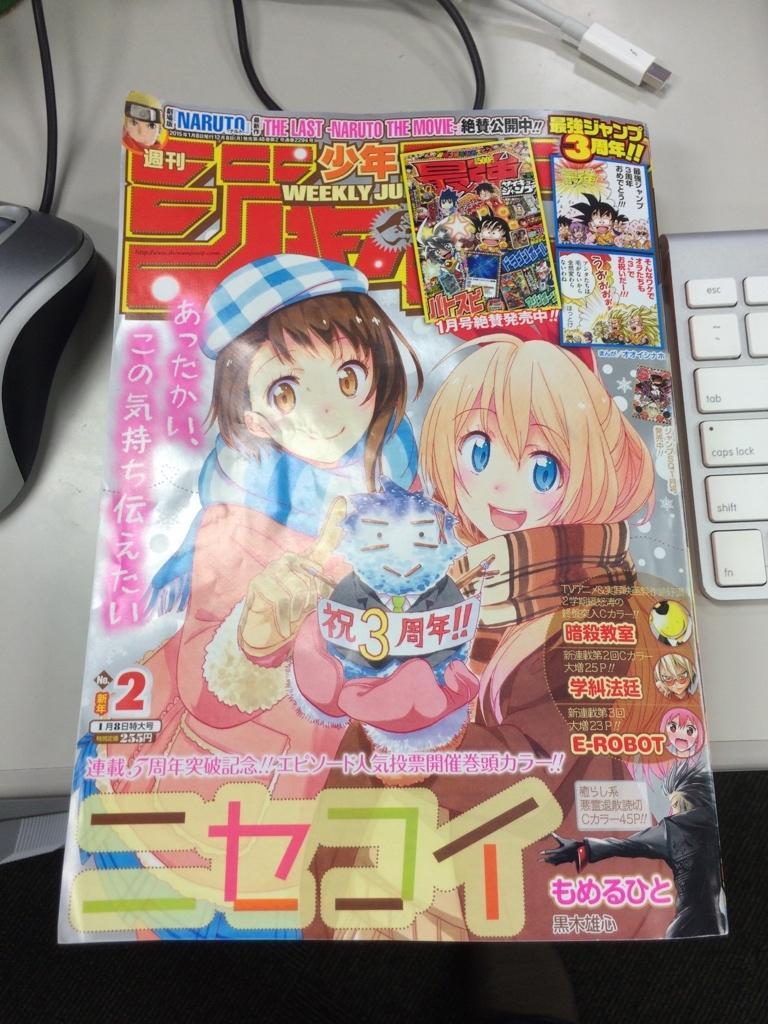How would you summarize this image in a sentence or two? In the picture we can see a magazine with some cartoon images on it and beside it we can see a part of keyboard which is white in color and on the other side of the magazine we can see a part of mouse which is black in color and on the top of it we can see a connection wire which is white in color. 